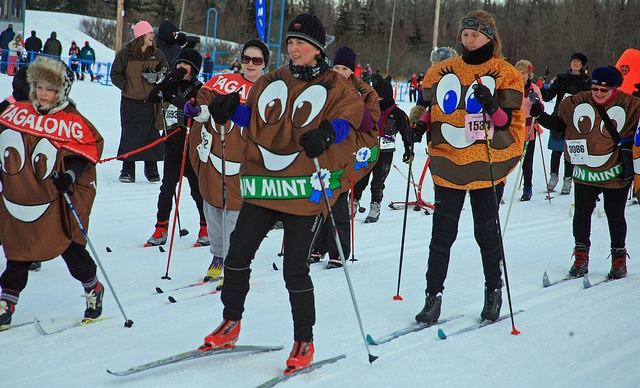Describe the objects in this image and their specific colors. I can see people in black, lightblue, and gray tones, people in black, maroon, lightblue, and red tones, people in black, red, maroon, and lightblue tones, people in black, maroon, and lightblue tones, and people in black, maroon, lightblue, and darkgray tones in this image. 